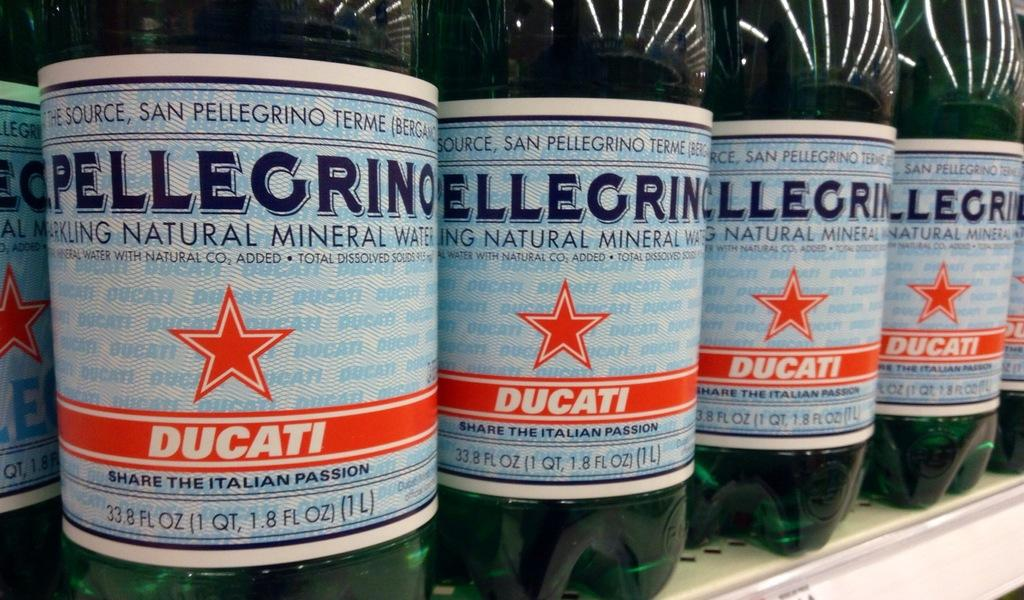<image>
Summarize the visual content of the image. Bottles of Pellegrino water are lined up on a shelf. 